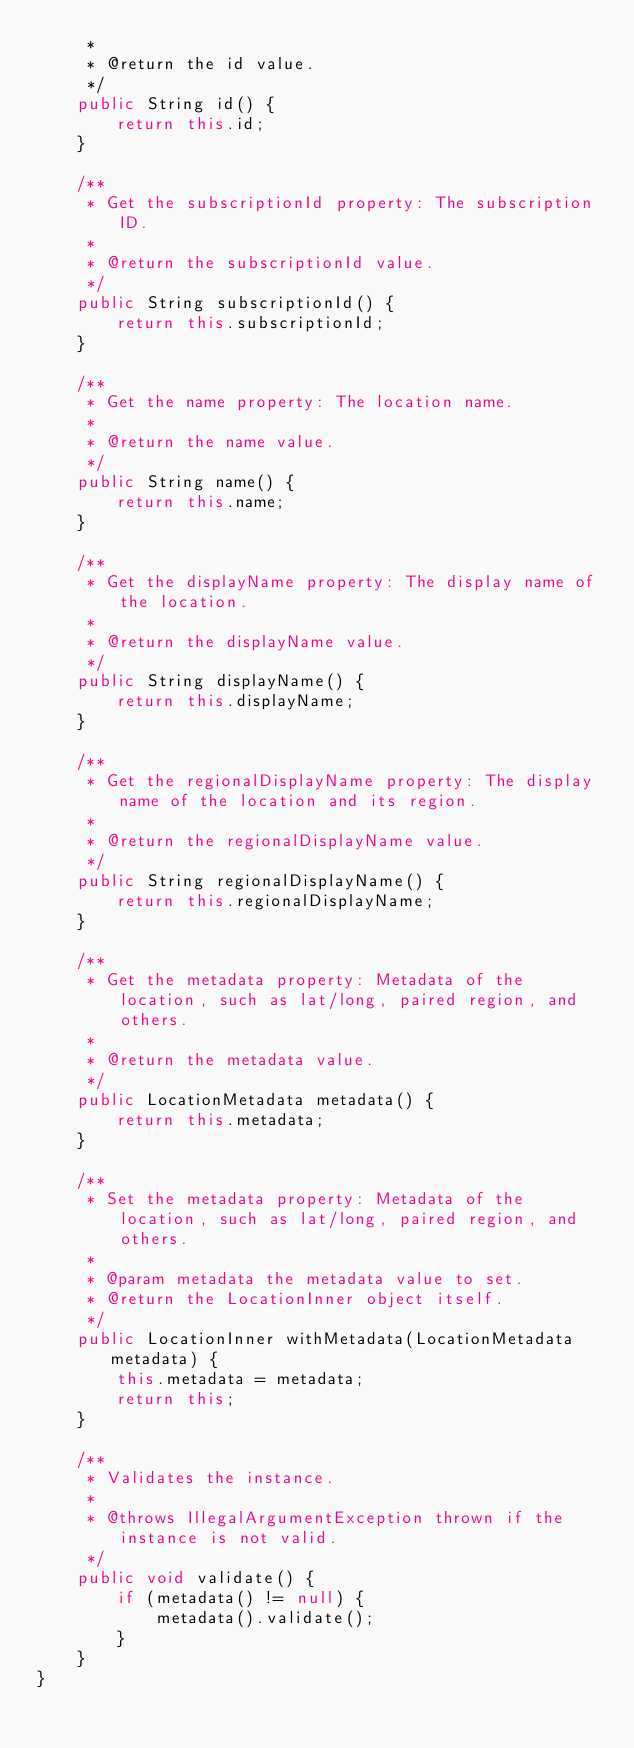Convert code to text. <code><loc_0><loc_0><loc_500><loc_500><_Java_>     *
     * @return the id value.
     */
    public String id() {
        return this.id;
    }

    /**
     * Get the subscriptionId property: The subscription ID.
     *
     * @return the subscriptionId value.
     */
    public String subscriptionId() {
        return this.subscriptionId;
    }

    /**
     * Get the name property: The location name.
     *
     * @return the name value.
     */
    public String name() {
        return this.name;
    }

    /**
     * Get the displayName property: The display name of the location.
     *
     * @return the displayName value.
     */
    public String displayName() {
        return this.displayName;
    }

    /**
     * Get the regionalDisplayName property: The display name of the location and its region.
     *
     * @return the regionalDisplayName value.
     */
    public String regionalDisplayName() {
        return this.regionalDisplayName;
    }

    /**
     * Get the metadata property: Metadata of the location, such as lat/long, paired region, and others.
     *
     * @return the metadata value.
     */
    public LocationMetadata metadata() {
        return this.metadata;
    }

    /**
     * Set the metadata property: Metadata of the location, such as lat/long, paired region, and others.
     *
     * @param metadata the metadata value to set.
     * @return the LocationInner object itself.
     */
    public LocationInner withMetadata(LocationMetadata metadata) {
        this.metadata = metadata;
        return this;
    }

    /**
     * Validates the instance.
     *
     * @throws IllegalArgumentException thrown if the instance is not valid.
     */
    public void validate() {
        if (metadata() != null) {
            metadata().validate();
        }
    }
}
</code> 